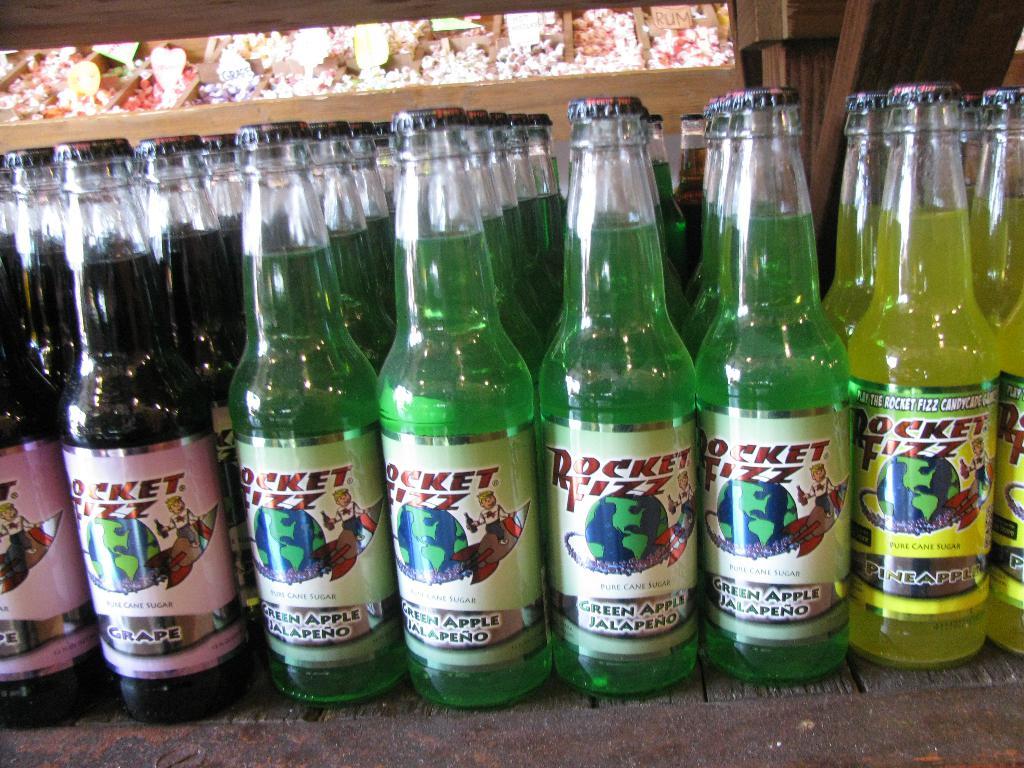How many different flavors are there?
Your answer should be compact. 3. 